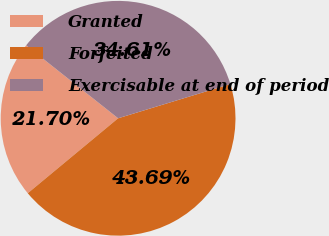Convert chart. <chart><loc_0><loc_0><loc_500><loc_500><pie_chart><fcel>Granted<fcel>Forfeited<fcel>Exercisable at end of period<nl><fcel>21.7%<fcel>43.69%<fcel>34.61%<nl></chart> 